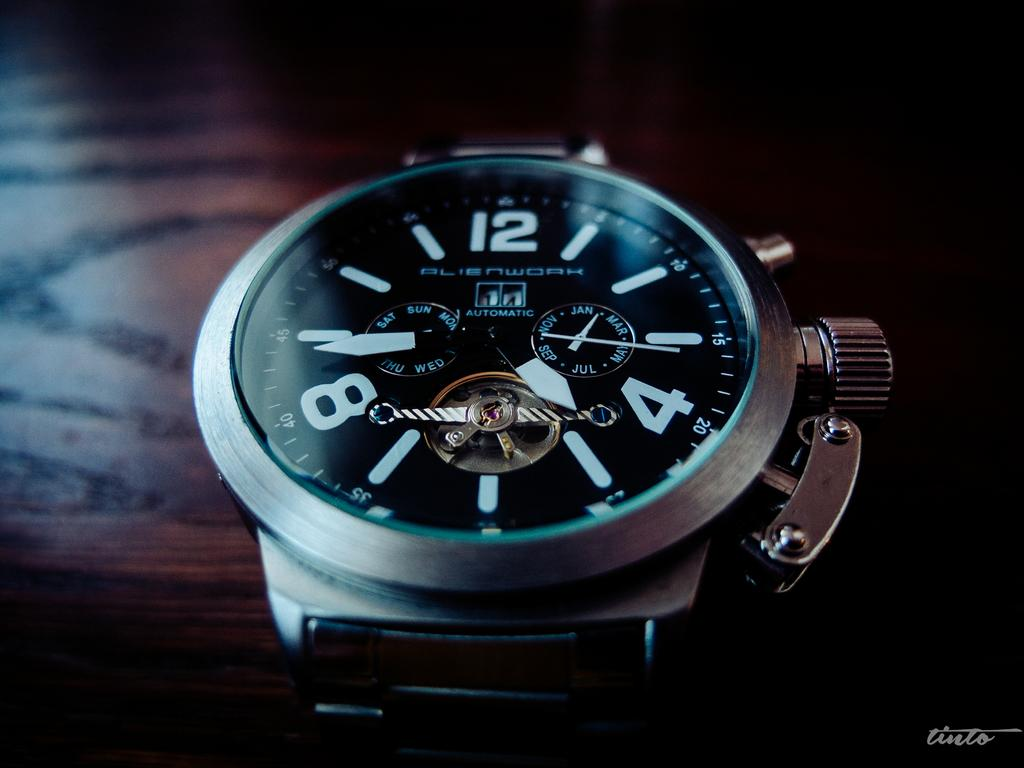What type of timepiece is visible in the image? There is a hand watch in the image. How close is the view of the hand watch in the image? The hand watch is in close view. What surface is the hand watch placed on in the image? The hand watch is placed on a wooden table top. How much sugar is in the hand watch in the image? There is no sugar present in the hand watch in the image, as it is a timepiece and not a food item. 